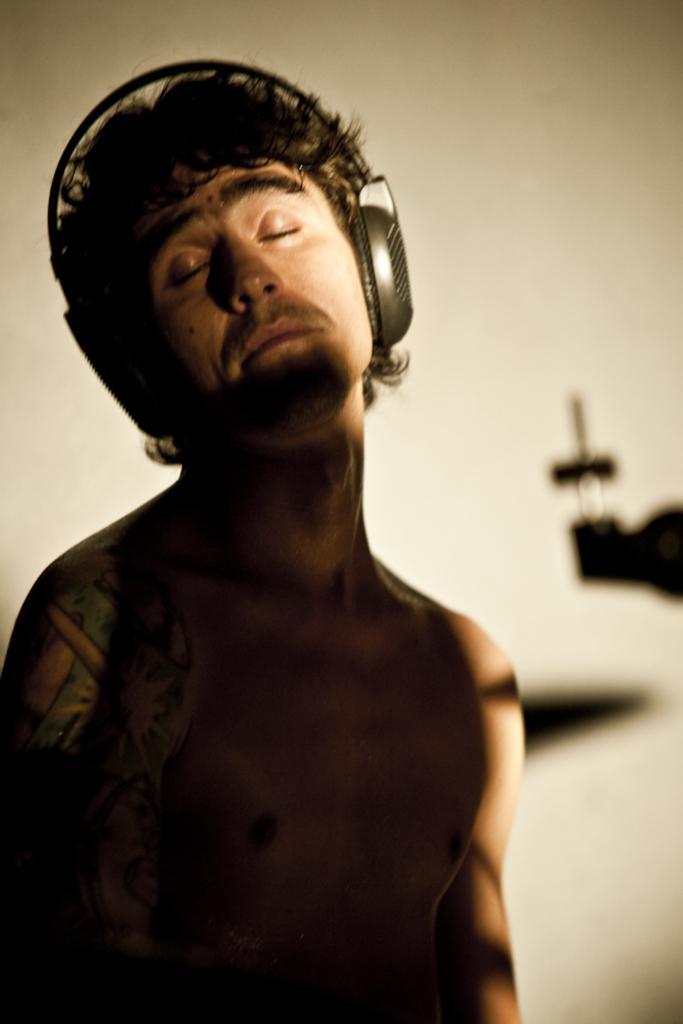In one or two sentences, can you explain what this image depicts? In this image in the foreground there is one person who is wearing a headset, and in the background there is a wall and shadow of some objects. 